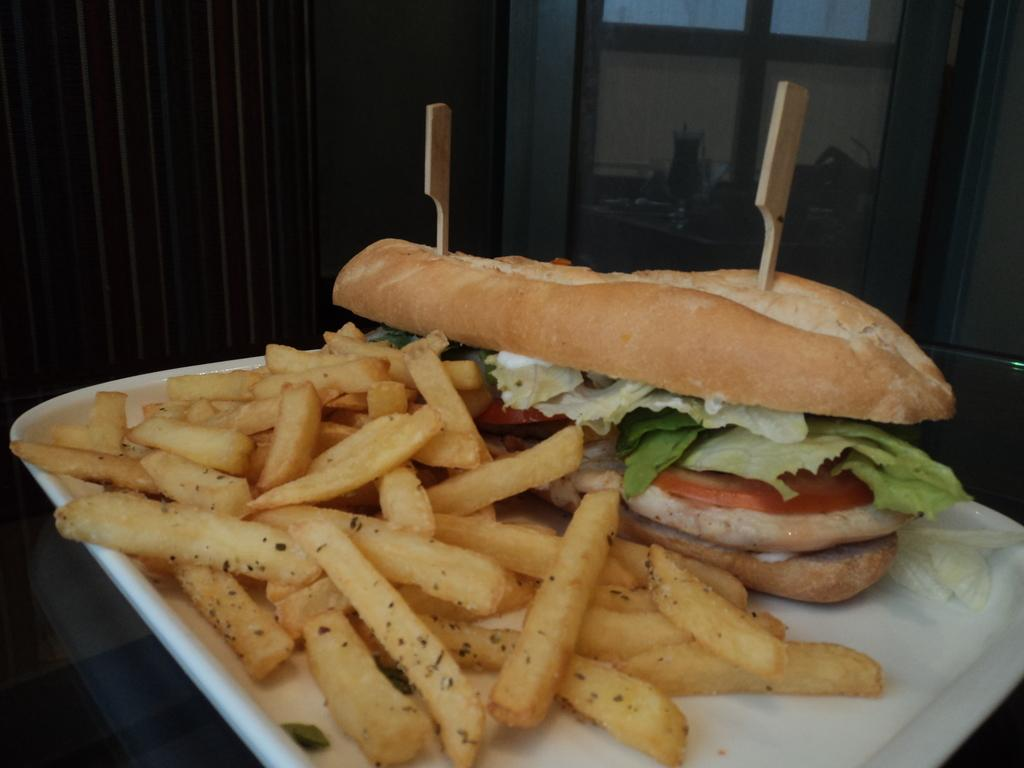What type of food can be seen in the image? There are french fries and a burger in the image. What is the color of the plate that the burger is on? The burger is on a white color plate. What type of coal is visible in the image? There is no coal present in the image. What grade of french fries can be seen in the image? The grade of french fries cannot be determined from the image. 